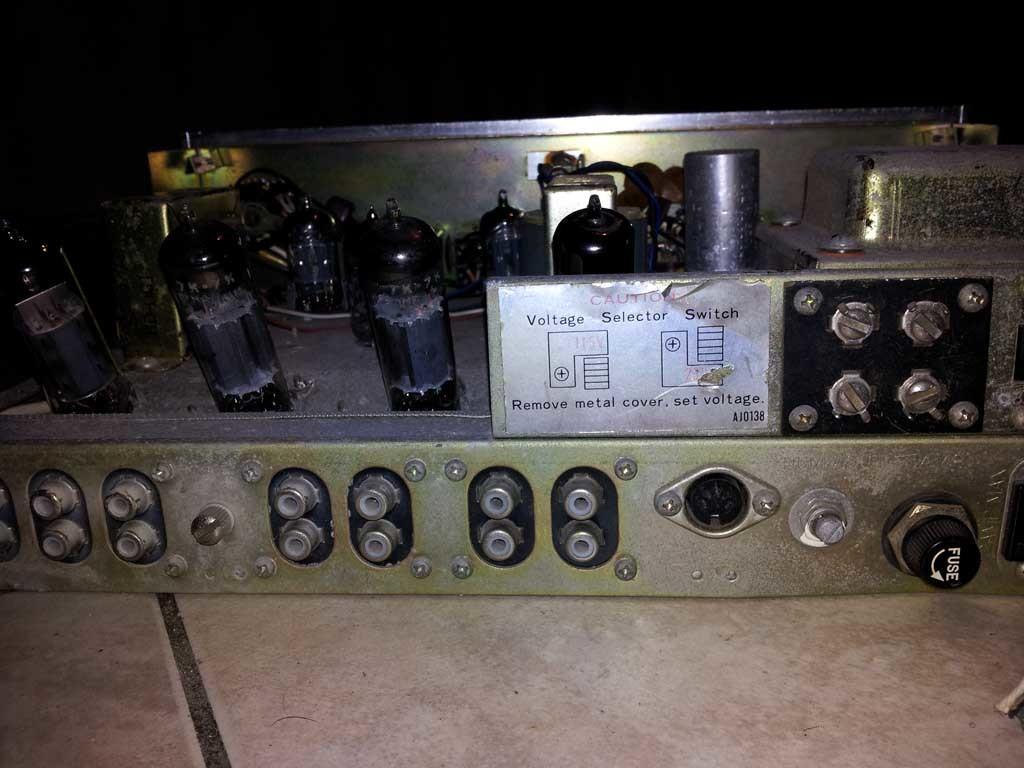How would you summarize this image in a sentence or two? Here I can see an electronic device which is placed on the floor. To this device I can see some knobs and a white color paper is attached to it. On this I can see some text. 